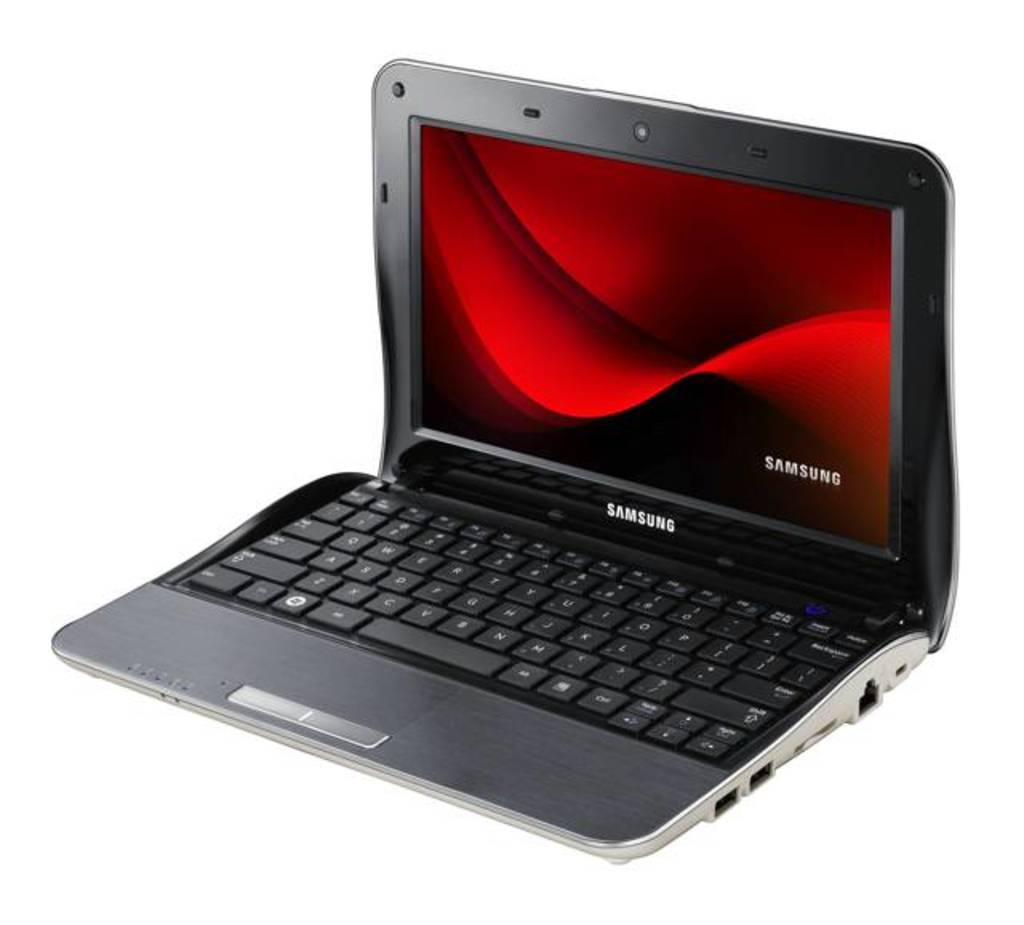Provide a one-sentence caption for the provided image. A SAMSUNG LAPTO WITH THE LID OPEN SHOWING RED SCREEN. 